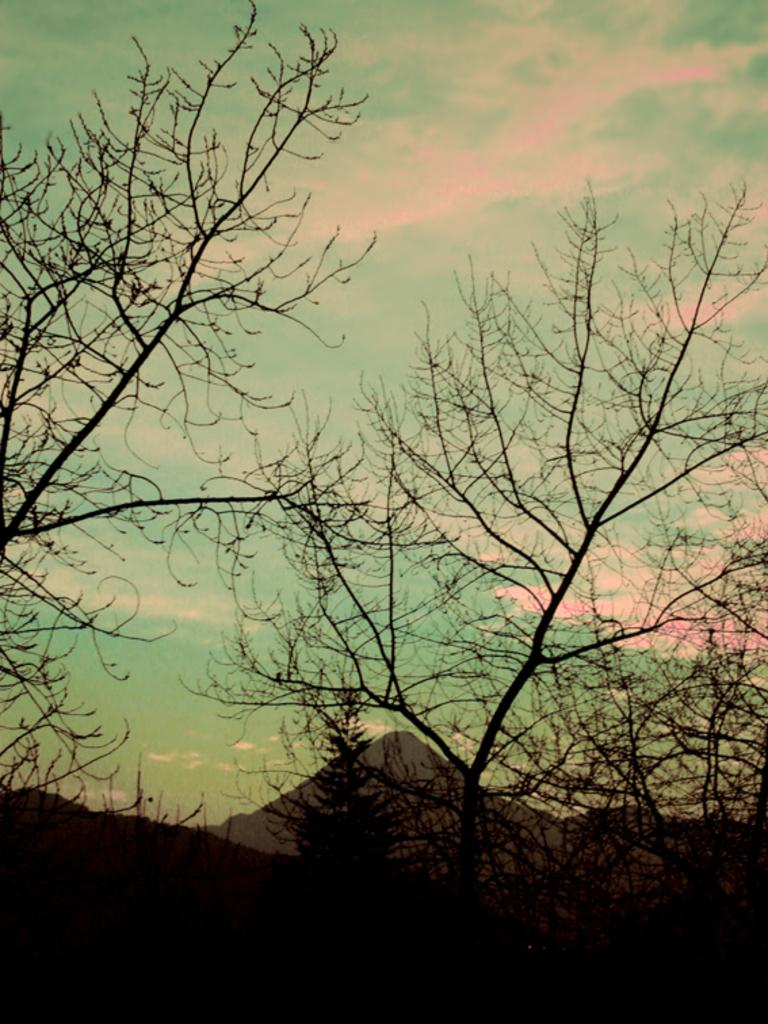What type of vegetation can be seen in the image? There are trees in the image. What natural feature is visible in the background of the image? There is a mountain in the background of the image. What else can be seen in the background of the image? The sky is visible in the background of the image. How many bits can be seen on the beggar's shoulder in the image? There is no beggar or bit present in the image. What type of hole can be seen in the mountain in the image? There is no hole visible in the mountain in the image. 